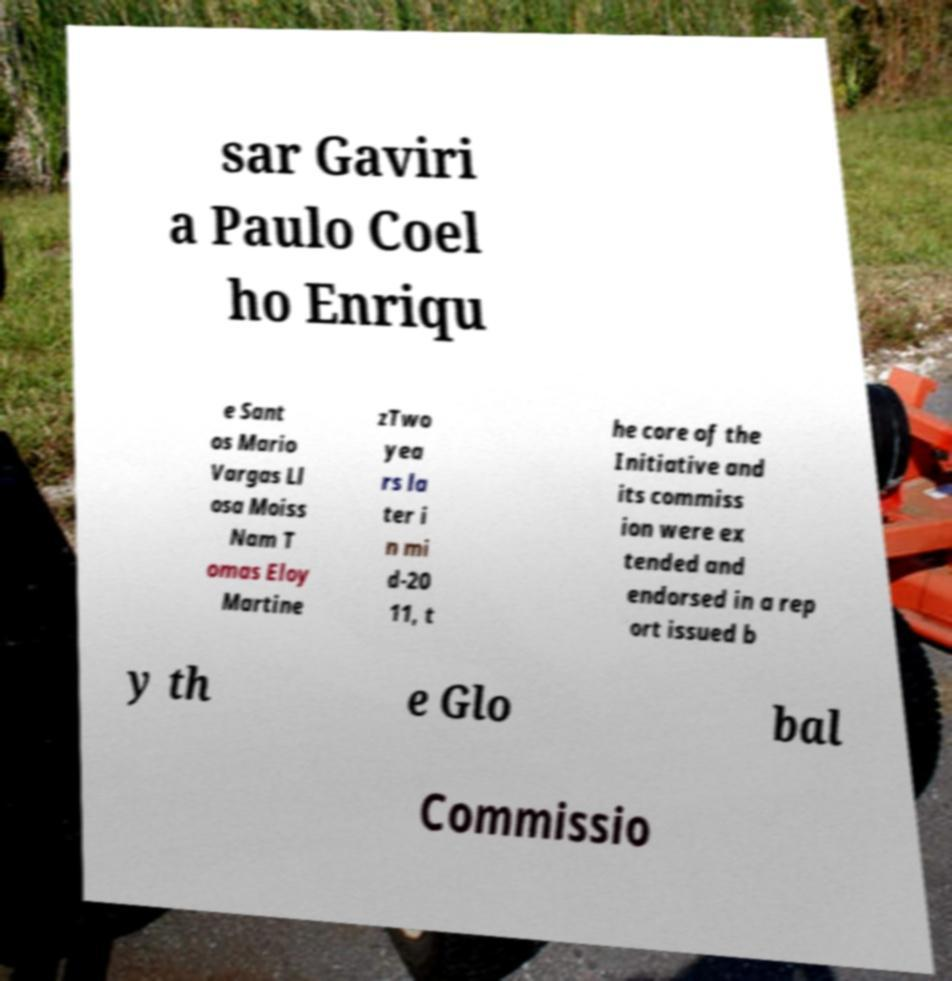Can you read and provide the text displayed in the image?This photo seems to have some interesting text. Can you extract and type it out for me? sar Gaviri a Paulo Coel ho Enriqu e Sant os Mario Vargas Ll osa Moiss Nam T omas Eloy Martine zTwo yea rs la ter i n mi d-20 11, t he core of the Initiative and its commiss ion were ex tended and endorsed in a rep ort issued b y th e Glo bal Commissio 